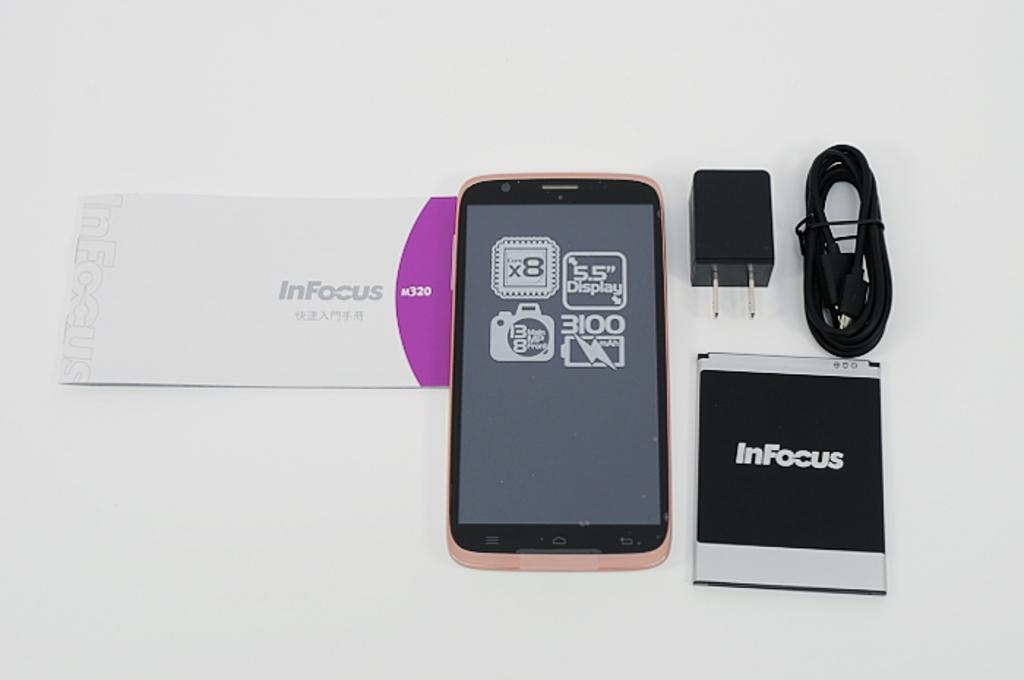<image>
Summarize the visual content of the image. a display of INFocus Cell phone and accessories 